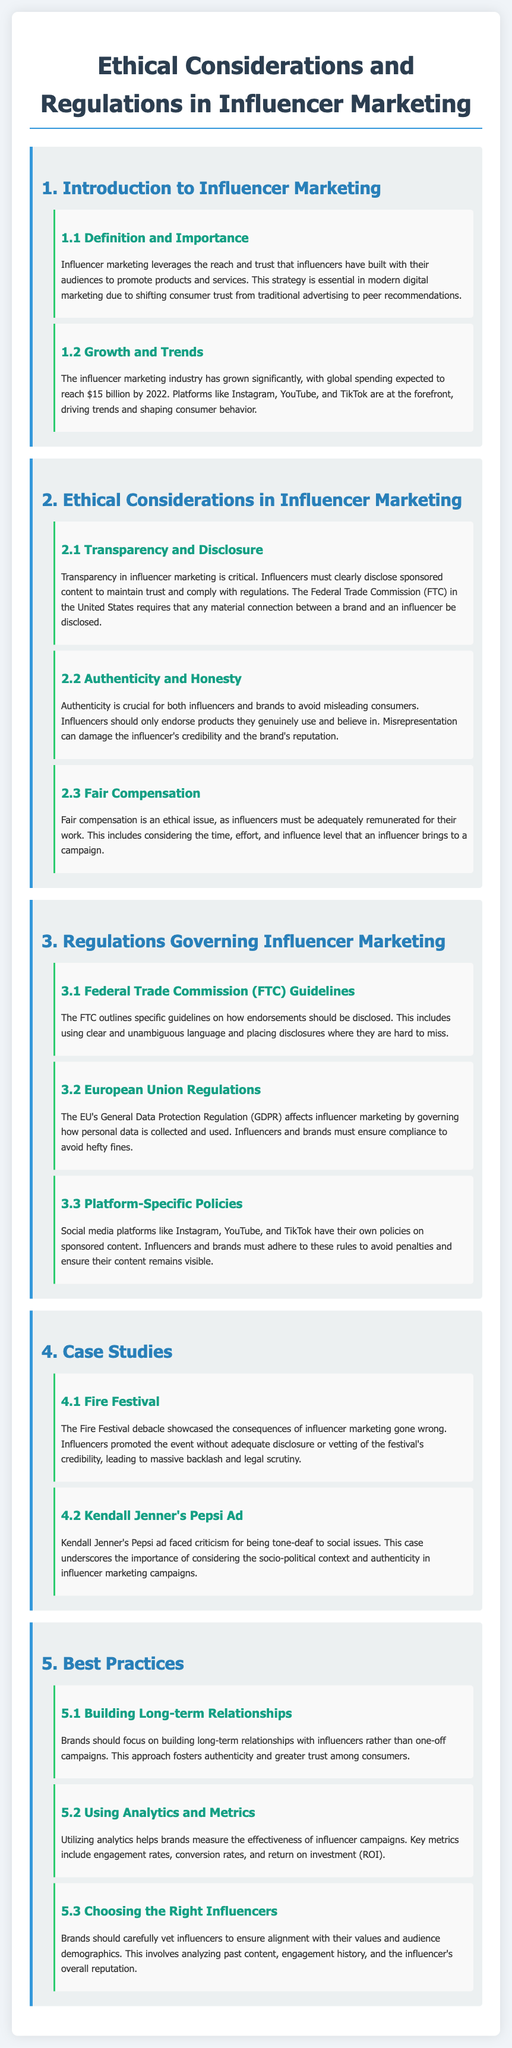What is the expected global spending on influencer marketing by 2022? The document states that global spending in the influencer marketing industry is expected to reach $15 billion by 2022.
Answer: $15 billion What does the FTC require regarding influencer marketing? The FTC requires that any material connection between a brand and an influencer be disclosed.
Answer: Disclosure What ethical issue involves adequate remuneration for influencers? The document refers to fair compensation as an ethical issue in influencer marketing.
Answer: Fair Compensation What principle does transparency in influencer marketing uphold? Transparency is critical for maintaining trust in influencer marketing.
Answer: Trust Which regulations govern personal data collection related to influencer marketing in the EU? The General Data Protection Regulation (GDPR) governs how personal data is collected and used in influencer marketing.
Answer: GDPR What is a significant consequence of the Fire Festival influencer marketing case? The Fire Festival incident showcased the consequences of influencer marketing gone wrong.
Answer: Backlash What type of relationship should brands focus on with influencers? The document recommends building long-term relationships with influencers.
Answer: Long-term Relationships Which social media platforms have their own sponsored content policies? The document mentions Instagram, YouTube, and TikTok as platforms with their own policies.
Answer: Instagram, YouTube, TikTok What is one of the key metrics to measure influencer campaign effectiveness? The document lists engagement rates as a key metric for measuring campaign effectiveness.
Answer: Engagement Rates 